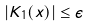<formula> <loc_0><loc_0><loc_500><loc_500>| K _ { 1 } ( { x } ) | \leq \epsilon</formula> 